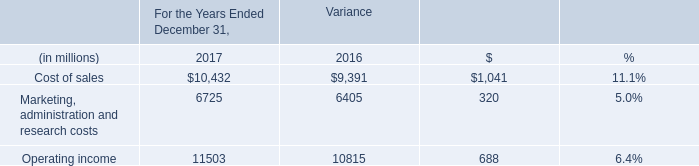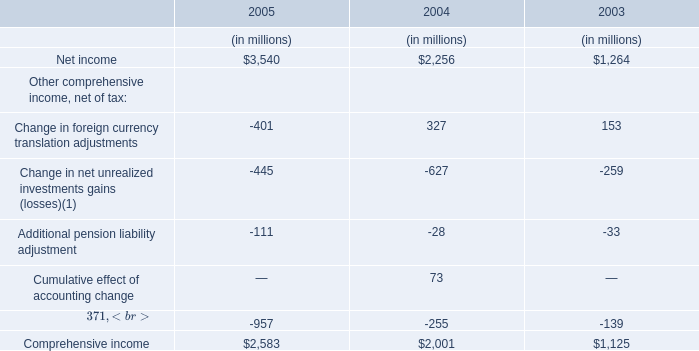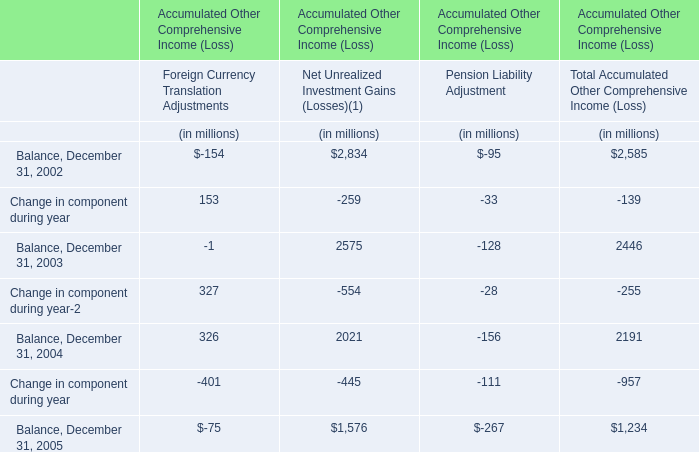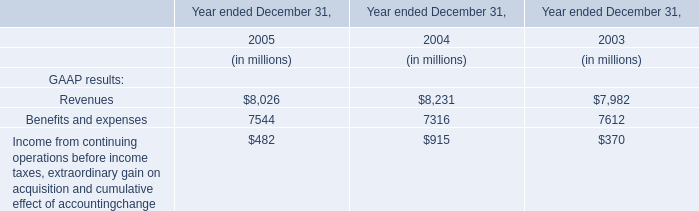What is the sum of Net income, Change in foreign currency translation adjustments and Change in net unrealized investments gains (losses)(1) in 2005? (in million) 
Computations: ((3540 - 401) - 445)
Answer: 2694.0. 